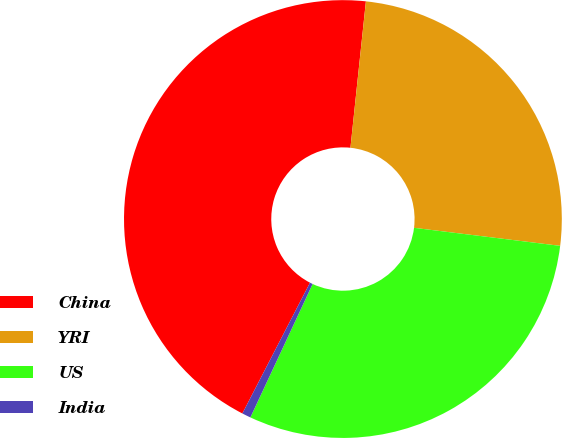<chart> <loc_0><loc_0><loc_500><loc_500><pie_chart><fcel>China<fcel>YRI<fcel>US<fcel>India<nl><fcel>44.08%<fcel>25.28%<fcel>29.99%<fcel>0.65%<nl></chart> 